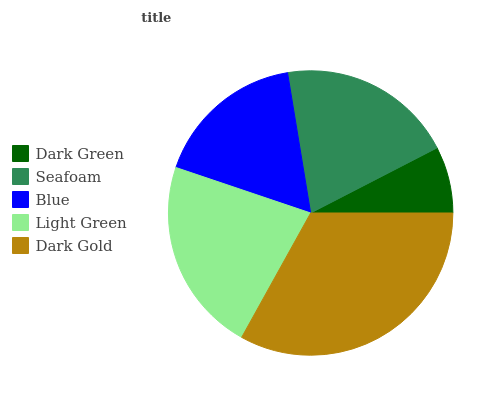Is Dark Green the minimum?
Answer yes or no. Yes. Is Dark Gold the maximum?
Answer yes or no. Yes. Is Seafoam the minimum?
Answer yes or no. No. Is Seafoam the maximum?
Answer yes or no. No. Is Seafoam greater than Dark Green?
Answer yes or no. Yes. Is Dark Green less than Seafoam?
Answer yes or no. Yes. Is Dark Green greater than Seafoam?
Answer yes or no. No. Is Seafoam less than Dark Green?
Answer yes or no. No. Is Seafoam the high median?
Answer yes or no. Yes. Is Seafoam the low median?
Answer yes or no. Yes. Is Dark Gold the high median?
Answer yes or no. No. Is Dark Gold the low median?
Answer yes or no. No. 